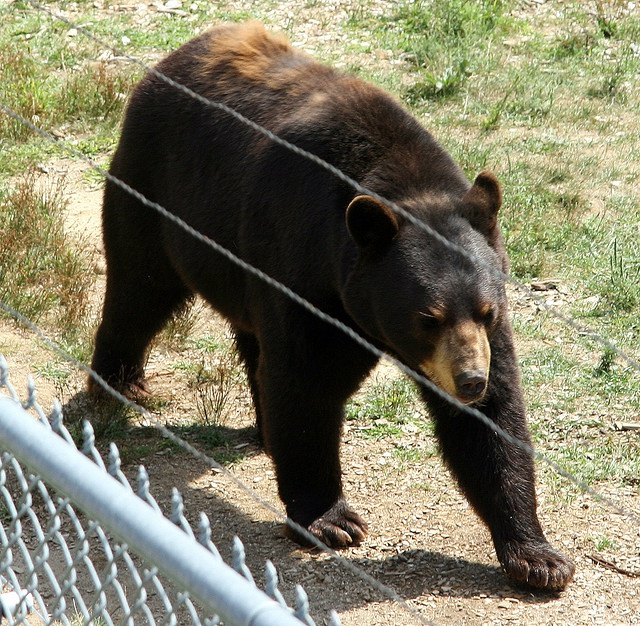Describe the objects in this image and their specific colors. I can see a bear in beige, black, gray, and maroon tones in this image. 